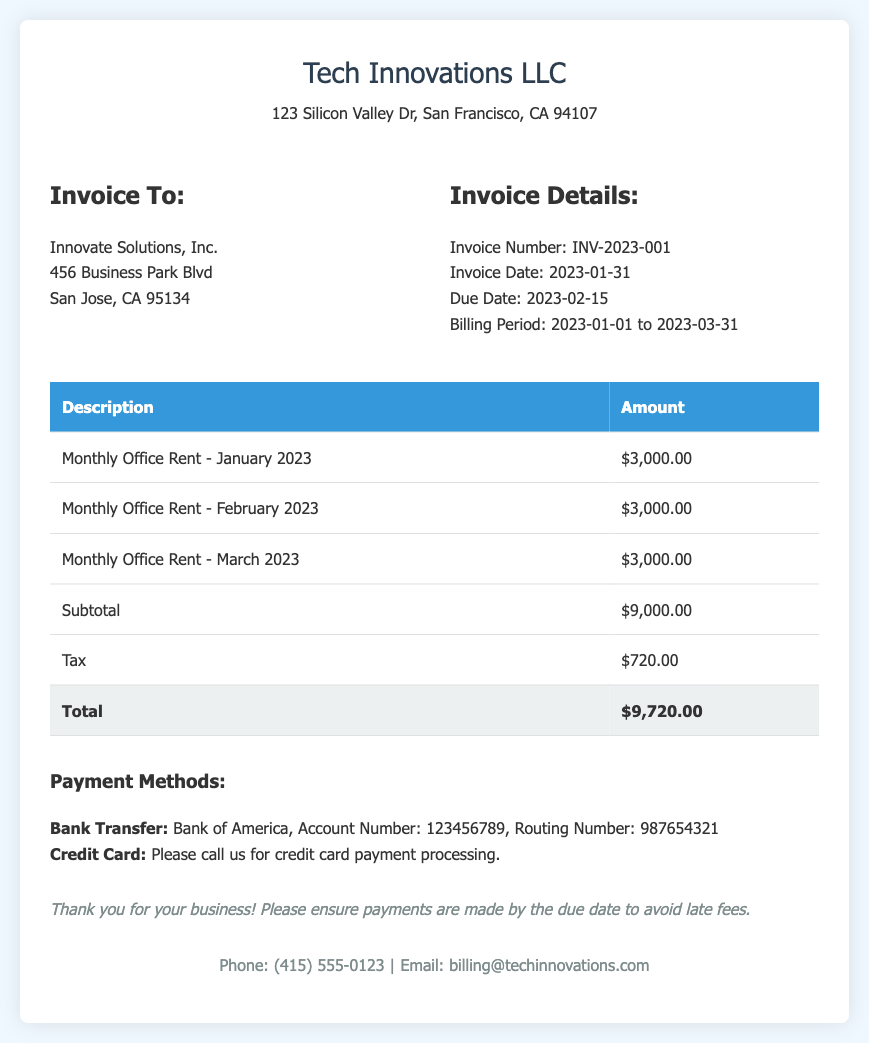What is the total rent for the office in Q1 2023? The total rent for the office is calculated from the itemized monthly rents listed, which sum up to $9,000.00.
Answer: $9,000.00 What is the due date for this invoice? The due date is explicitly stated in the invoice details section.
Answer: 2023-02-15 How much tax is included in the invoice? The tax amount is listed in the itemized payment details as a separate entry.
Answer: $720.00 Who is the billing contact for the invoice? The contact information in the document includes a specific email address for billing inquiries.
Answer: billing@techinnovations.com How many months is the billing period for this invoice? The billing period spans from January to March, which is a total of three months.
Answer: 3 months What payment methods are available for this invoice? The payment methods are clearly outlined in a specific section of the document.
Answer: Bank Transfer, Credit Card What is the invoice number? The unique identifier for this invoice is given in the invoice details section.
Answer: INV-2023-001 What is the subtotal amount before tax? The subtotal line in the invoice summarizes the total before tax is added.
Answer: $9,000.00 Who is the invoice addressed to? The recipient's name and address are provided in the "Invoice To" section.
Answer: Innovate Solutions, Inc 